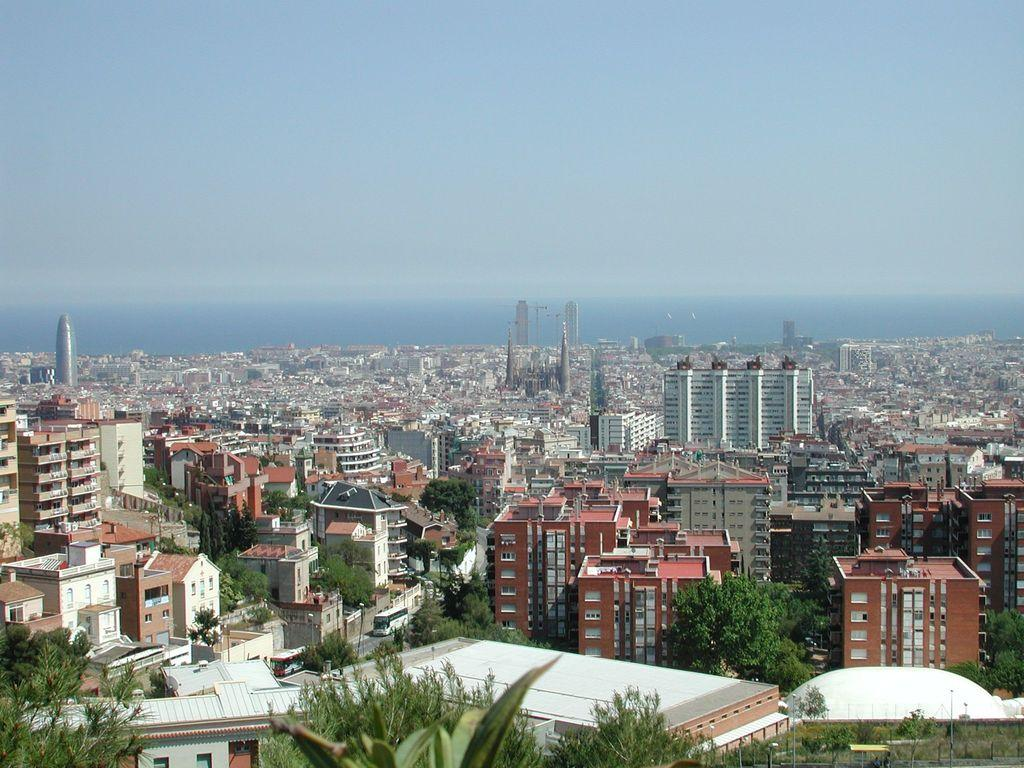What type of location is depicted in the image? The image is of a city. What structures can be seen in the city? There are buildings in the image. Are there any natural elements present in the city? Yes, there are trees in the image. What can be seen in the distance in the image? The sky is visible in the background of the image. What type of cloth is draped over the buildings in the image? There is no cloth draped over the buildings in the image; the buildings are not covered. 